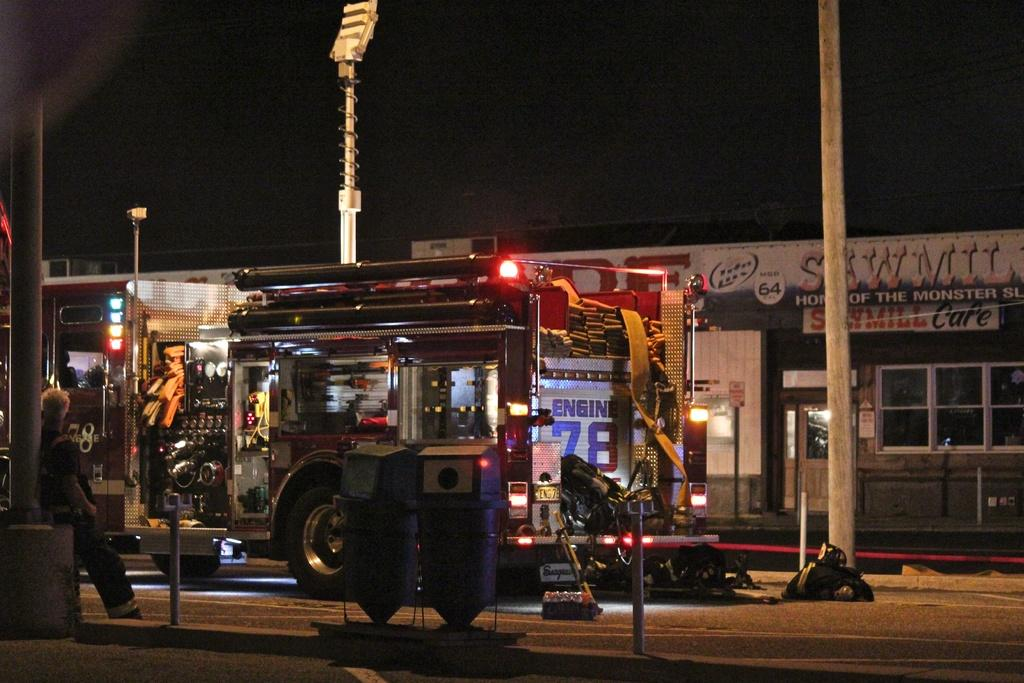What vehicle is on the road in the image? There is a fire engine on the road in the image. What objects are present near the fire engine? There are bins in the image. Can you describe the person in the image? There is a person in the image. What type of structures can be seen in the background? There are poles and stores visible in the background. What is visible in the sky in the image? The sky is visible in the background. What is the price of the balloon being sold at the farm in the image? There is no balloon or farm present in the image. 